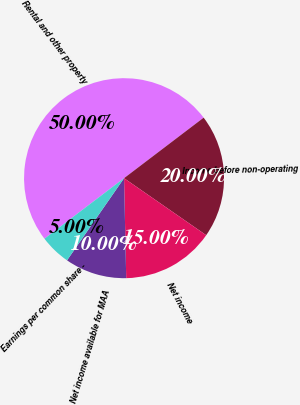Convert chart. <chart><loc_0><loc_0><loc_500><loc_500><pie_chart><fcel>Rental and other property<fcel>Income before non-operating<fcel>Net income<fcel>Net income available for MAA<fcel>Earnings per common share -<nl><fcel>50.0%<fcel>20.0%<fcel>15.0%<fcel>10.0%<fcel>5.0%<nl></chart> 